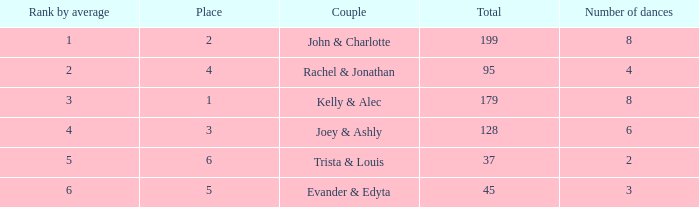What is the highest average that has 6 dances and a total of over 128? None. 